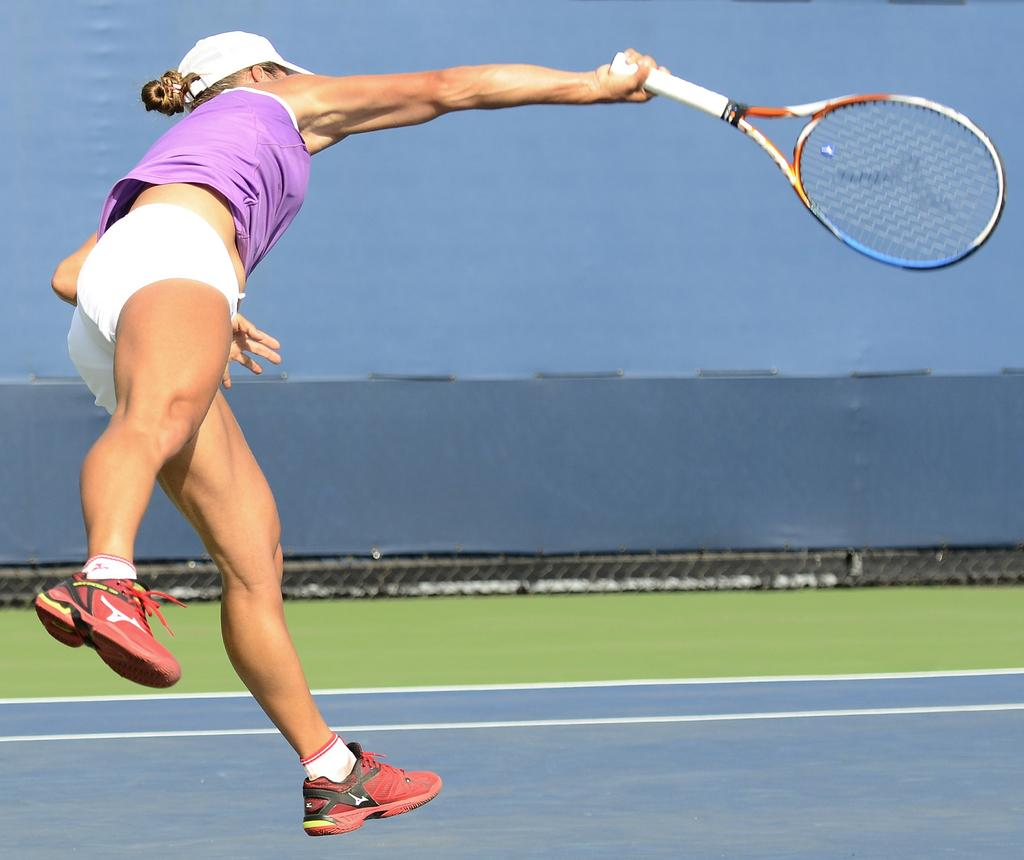What is the main subject of the image? The main subject of the image is a woman. What is the woman doing in the image? The woman is playing with a tennis racket. Can you see a snake slithering around the tennis racket in the image? No, there is no snake present in the image. What type of stem is visible on the tennis racket in the image? There is no stem present on the tennis racket in the image. 